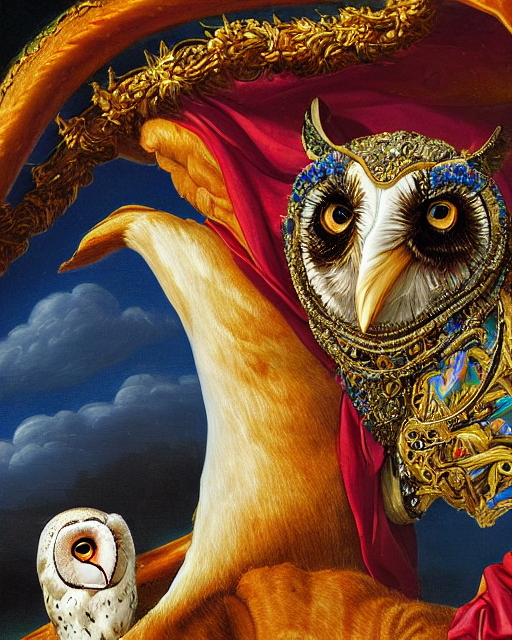Could you elaborate on the symbolism of the owl within this work? In many cultures, owls are symbols of wisdom and knowledge, often associated with the Greek goddess Athena. In this artwork, the owl's prominent position and ornate attire might symbolize the importance of seeking knowledge beyond the superficial, encouraging the viewers to look deeper into the mysteries of life. 